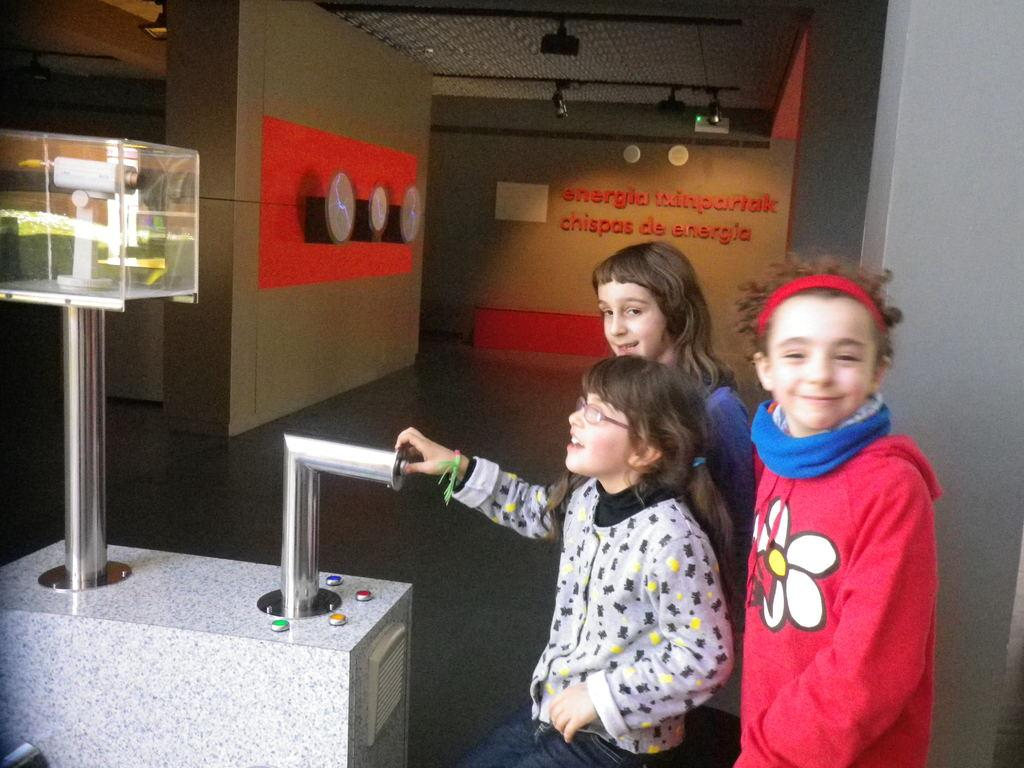How many children are present in the image? There are three children in the image. What is the setting of the image? The image appears to be taken in a room. What can be seen in the front of the image? There is a machine in the front of the image. What is visible in the background of the image? There are walls in the background of the image. What is the surface beneath the children's feet? There is a floor at the bottom of the image. What type of wool is being spun by the children in the image? There is no wool or spinning apparatus present in the image; the children are not engaged in any such activity. 